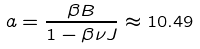<formula> <loc_0><loc_0><loc_500><loc_500>a = \frac { \beta B } { 1 - \beta \nu J } \approx 1 0 . 4 9</formula> 